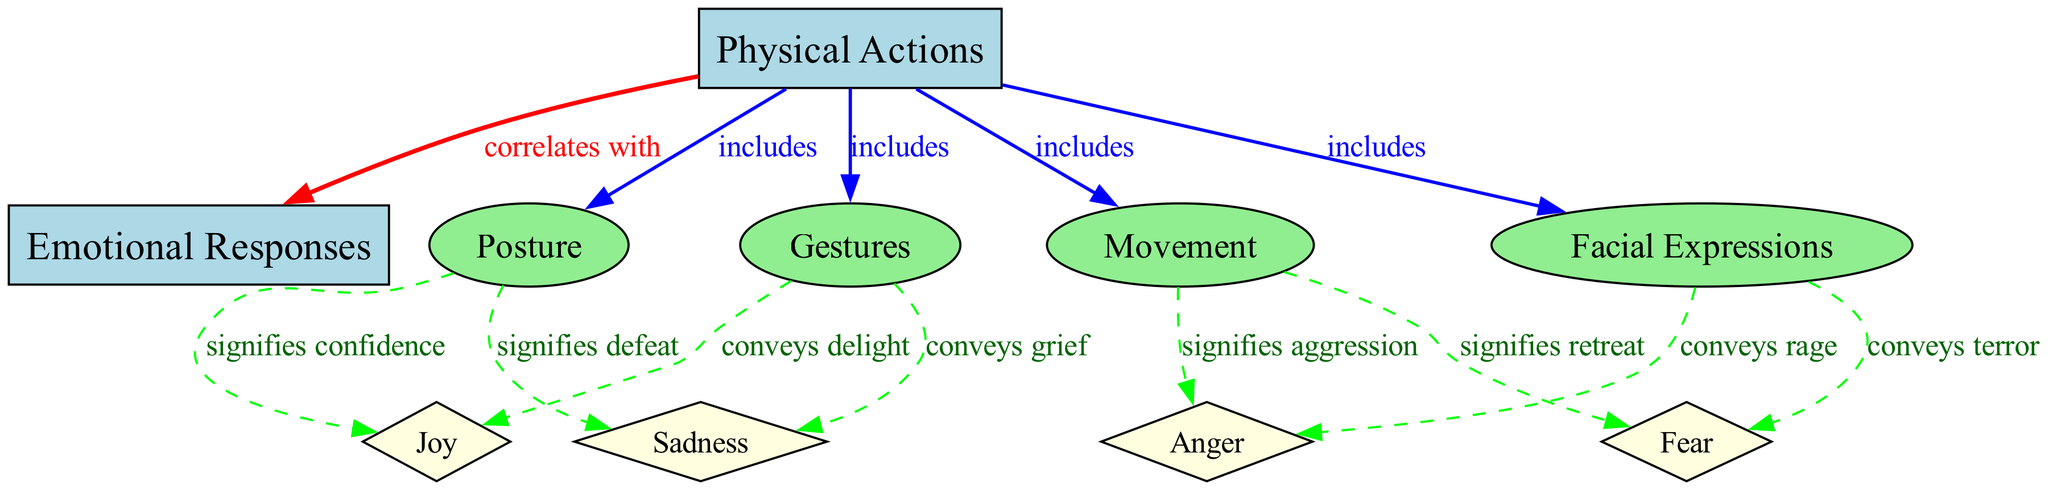What are the main categories of physical actions? The diagram shows that the main categories of physical actions include gestures, facial expressions, posture, and movement. Each category is represented as an ellipse branching from the main node "Physical Actions."
Answer: gestures, facial expressions, posture, movement How many emotional responses are depicted in the diagram? The diagram lists four emotional responses: joy, sadness, anger, and fear. Each one is represented as a diamond shape stemming from the "Emotional Responses" node.
Answer: four What emotional response does a gesture convey? According to the diagram, gestures convey joy and sadness, indicating that physical actions in the form of gestures can express both delight and grief.
Answer: joy and sadness Which physical action signifies confidence? The diagram indicates that the physical action of posture signifies confidence, connecting posture directly to this emotional response.
Answer: posture What are the emotional responses associated with facial expressions? The diagram states that facial expressions convey anger and fear. This means that specific expressions can represent these intense emotional states during a performance.
Answer: anger and fear How does movement relate to emotional expression? The diagram illustrates that movement signifies aggression and retreat. Therefore, the way a performer moves can impact how aggression or retreat is perceived by the audience.
Answer: aggression and retreat Which physical action includes gestures? The diagram specifies that physical actions include gestures. This indicates that gestures are a component of the broader category of physical actions utilized in performance.
Answer: gestures What is the connection between physical actions and emotional responses? The diagram shows that physical actions correlate with emotional responses, meaning that the way an actor physically expresses themselves is directly linked to the emotions conveyed in the performance.
Answer: correlate with Are there more edges leading out from physical actions or emotional responses? There are more edges leading out from physical actions, as it connects to four different physical action types, while emotional responses only connect back to four emotions. This indicates a broader range of physical actions.
Answer: more edges from physical actions 